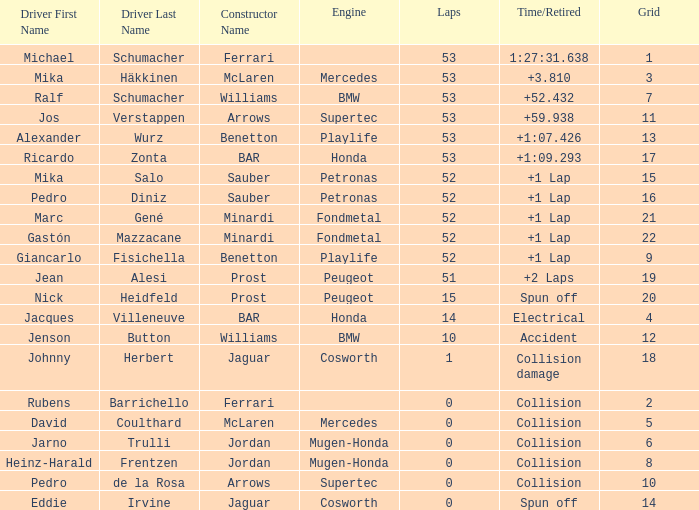Which grid number has fewer than 52 laps, a time/retired status due to collision, and is part of the arrows-supertec constructor team? 1.0. 